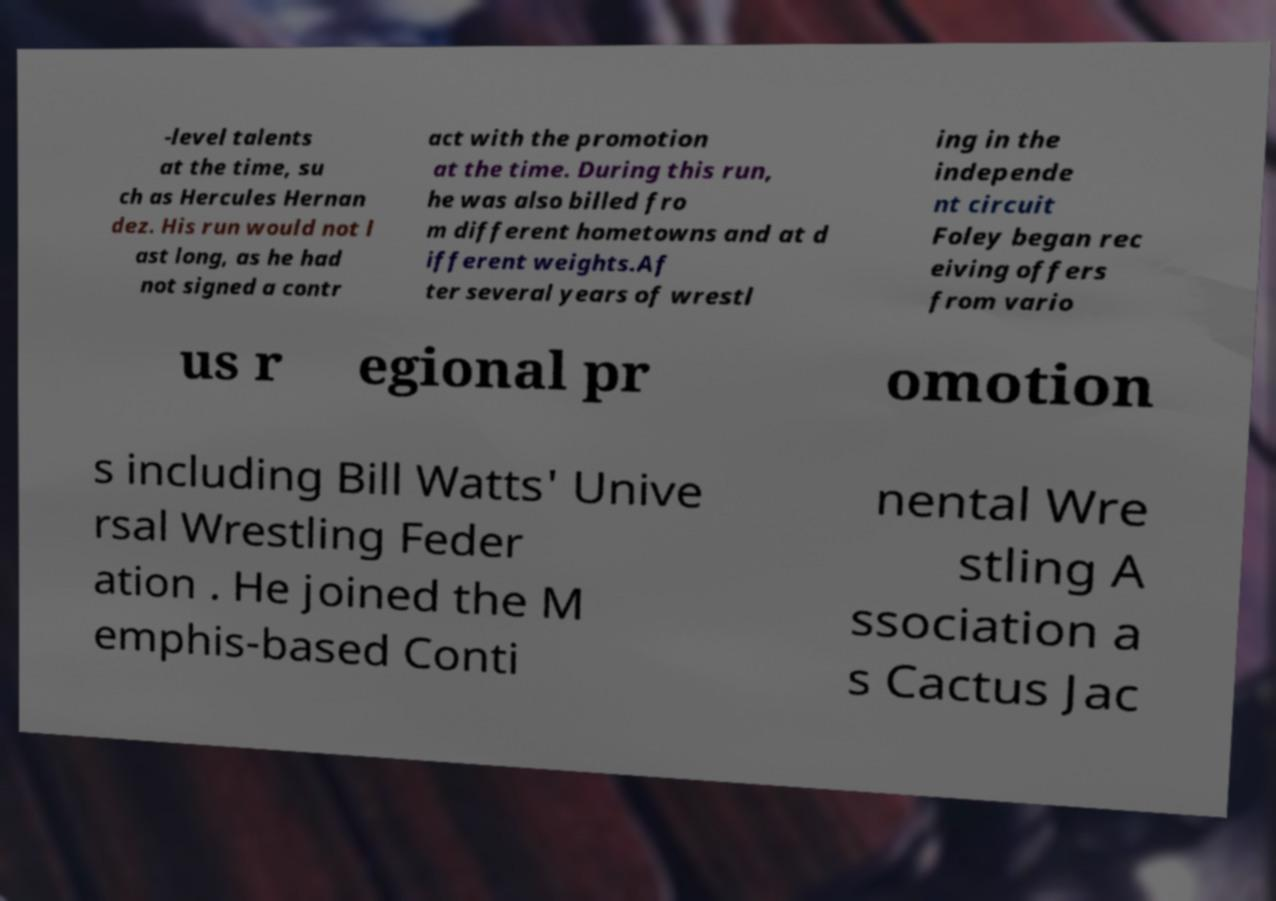Please read and relay the text visible in this image. What does it say? -level talents at the time, su ch as Hercules Hernan dez. His run would not l ast long, as he had not signed a contr act with the promotion at the time. During this run, he was also billed fro m different hometowns and at d ifferent weights.Af ter several years of wrestl ing in the independe nt circuit Foley began rec eiving offers from vario us r egional pr omotion s including Bill Watts' Unive rsal Wrestling Feder ation . He joined the M emphis-based Conti nental Wre stling A ssociation a s Cactus Jac 